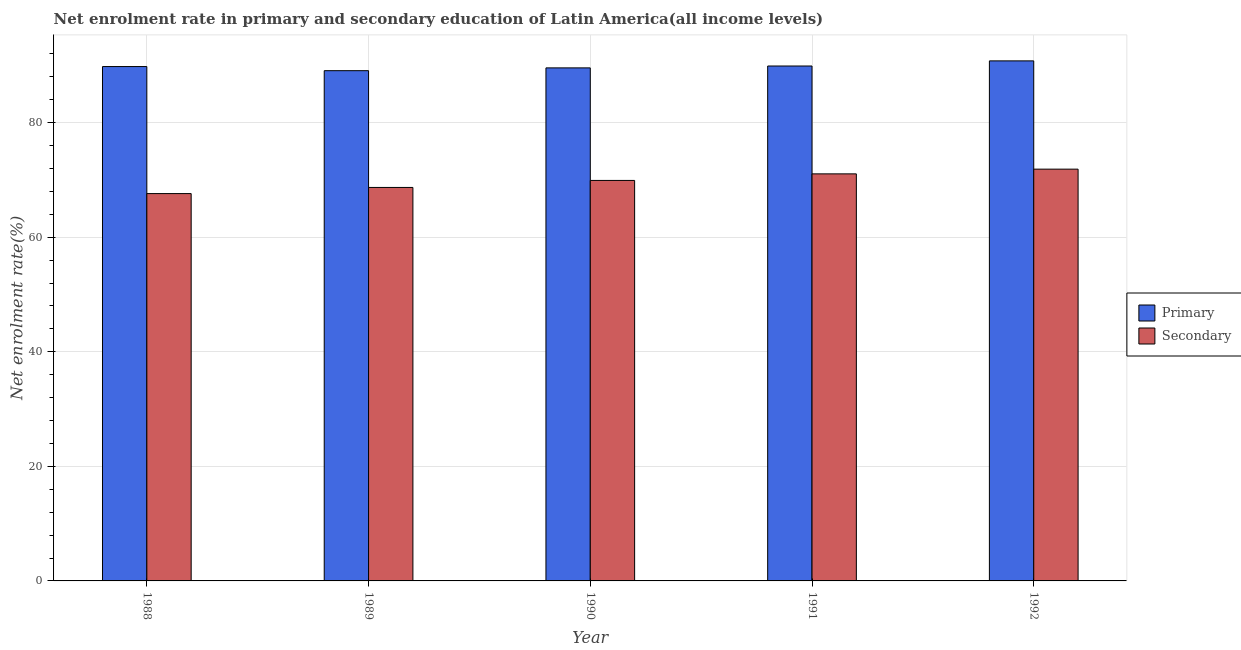How many different coloured bars are there?
Provide a short and direct response. 2. How many groups of bars are there?
Your answer should be compact. 5. What is the enrollment rate in primary education in 1988?
Provide a short and direct response. 89.8. Across all years, what is the maximum enrollment rate in primary education?
Keep it short and to the point. 90.79. Across all years, what is the minimum enrollment rate in primary education?
Keep it short and to the point. 89.08. What is the total enrollment rate in secondary education in the graph?
Keep it short and to the point. 349.18. What is the difference between the enrollment rate in secondary education in 1988 and that in 1990?
Keep it short and to the point. -2.3. What is the difference between the enrollment rate in secondary education in 1990 and the enrollment rate in primary education in 1989?
Your response must be concise. 1.22. What is the average enrollment rate in secondary education per year?
Ensure brevity in your answer.  69.84. What is the ratio of the enrollment rate in primary education in 1988 to that in 1990?
Your response must be concise. 1. Is the enrollment rate in primary education in 1988 less than that in 1991?
Offer a very short reply. Yes. Is the difference between the enrollment rate in secondary education in 1989 and 1992 greater than the difference between the enrollment rate in primary education in 1989 and 1992?
Offer a very short reply. No. What is the difference between the highest and the second highest enrollment rate in primary education?
Give a very brief answer. 0.9. What is the difference between the highest and the lowest enrollment rate in primary education?
Offer a very short reply. 1.71. Is the sum of the enrollment rate in secondary education in 1990 and 1992 greater than the maximum enrollment rate in primary education across all years?
Provide a succinct answer. Yes. What does the 2nd bar from the left in 1991 represents?
Keep it short and to the point. Secondary. What does the 2nd bar from the right in 1990 represents?
Offer a terse response. Primary. Are all the bars in the graph horizontal?
Your response must be concise. No. How many years are there in the graph?
Ensure brevity in your answer.  5. What is the difference between two consecutive major ticks on the Y-axis?
Provide a succinct answer. 20. Are the values on the major ticks of Y-axis written in scientific E-notation?
Provide a short and direct response. No. How many legend labels are there?
Provide a succinct answer. 2. What is the title of the graph?
Give a very brief answer. Net enrolment rate in primary and secondary education of Latin America(all income levels). What is the label or title of the X-axis?
Provide a succinct answer. Year. What is the label or title of the Y-axis?
Give a very brief answer. Net enrolment rate(%). What is the Net enrolment rate(%) in Primary in 1988?
Offer a very short reply. 89.8. What is the Net enrolment rate(%) of Secondary in 1988?
Make the answer very short. 67.62. What is the Net enrolment rate(%) of Primary in 1989?
Your answer should be compact. 89.08. What is the Net enrolment rate(%) of Secondary in 1989?
Your answer should be compact. 68.69. What is the Net enrolment rate(%) in Primary in 1990?
Ensure brevity in your answer.  89.57. What is the Net enrolment rate(%) in Secondary in 1990?
Your answer should be compact. 69.92. What is the Net enrolment rate(%) of Primary in 1991?
Your response must be concise. 89.89. What is the Net enrolment rate(%) of Secondary in 1991?
Ensure brevity in your answer.  71.06. What is the Net enrolment rate(%) in Primary in 1992?
Offer a very short reply. 90.79. What is the Net enrolment rate(%) in Secondary in 1992?
Provide a succinct answer. 71.89. Across all years, what is the maximum Net enrolment rate(%) in Primary?
Ensure brevity in your answer.  90.79. Across all years, what is the maximum Net enrolment rate(%) in Secondary?
Keep it short and to the point. 71.89. Across all years, what is the minimum Net enrolment rate(%) of Primary?
Offer a terse response. 89.08. Across all years, what is the minimum Net enrolment rate(%) of Secondary?
Ensure brevity in your answer.  67.62. What is the total Net enrolment rate(%) of Primary in the graph?
Keep it short and to the point. 449.13. What is the total Net enrolment rate(%) in Secondary in the graph?
Give a very brief answer. 349.18. What is the difference between the Net enrolment rate(%) of Primary in 1988 and that in 1989?
Keep it short and to the point. 0.72. What is the difference between the Net enrolment rate(%) of Secondary in 1988 and that in 1989?
Provide a short and direct response. -1.07. What is the difference between the Net enrolment rate(%) of Primary in 1988 and that in 1990?
Your response must be concise. 0.23. What is the difference between the Net enrolment rate(%) in Secondary in 1988 and that in 1990?
Offer a very short reply. -2.3. What is the difference between the Net enrolment rate(%) in Primary in 1988 and that in 1991?
Your answer should be very brief. -0.1. What is the difference between the Net enrolment rate(%) in Secondary in 1988 and that in 1991?
Your answer should be compact. -3.44. What is the difference between the Net enrolment rate(%) of Primary in 1988 and that in 1992?
Provide a short and direct response. -0.99. What is the difference between the Net enrolment rate(%) of Secondary in 1988 and that in 1992?
Keep it short and to the point. -4.27. What is the difference between the Net enrolment rate(%) of Primary in 1989 and that in 1990?
Keep it short and to the point. -0.49. What is the difference between the Net enrolment rate(%) of Secondary in 1989 and that in 1990?
Your answer should be very brief. -1.22. What is the difference between the Net enrolment rate(%) of Primary in 1989 and that in 1991?
Ensure brevity in your answer.  -0.81. What is the difference between the Net enrolment rate(%) in Secondary in 1989 and that in 1991?
Ensure brevity in your answer.  -2.37. What is the difference between the Net enrolment rate(%) in Primary in 1989 and that in 1992?
Provide a short and direct response. -1.71. What is the difference between the Net enrolment rate(%) in Secondary in 1989 and that in 1992?
Your response must be concise. -3.19. What is the difference between the Net enrolment rate(%) of Primary in 1990 and that in 1991?
Keep it short and to the point. -0.33. What is the difference between the Net enrolment rate(%) of Secondary in 1990 and that in 1991?
Make the answer very short. -1.15. What is the difference between the Net enrolment rate(%) of Primary in 1990 and that in 1992?
Ensure brevity in your answer.  -1.22. What is the difference between the Net enrolment rate(%) of Secondary in 1990 and that in 1992?
Your response must be concise. -1.97. What is the difference between the Net enrolment rate(%) of Primary in 1991 and that in 1992?
Your answer should be very brief. -0.9. What is the difference between the Net enrolment rate(%) of Secondary in 1991 and that in 1992?
Your response must be concise. -0.82. What is the difference between the Net enrolment rate(%) of Primary in 1988 and the Net enrolment rate(%) of Secondary in 1989?
Your answer should be very brief. 21.1. What is the difference between the Net enrolment rate(%) of Primary in 1988 and the Net enrolment rate(%) of Secondary in 1990?
Your answer should be compact. 19.88. What is the difference between the Net enrolment rate(%) in Primary in 1988 and the Net enrolment rate(%) in Secondary in 1991?
Provide a short and direct response. 18.73. What is the difference between the Net enrolment rate(%) of Primary in 1988 and the Net enrolment rate(%) of Secondary in 1992?
Provide a succinct answer. 17.91. What is the difference between the Net enrolment rate(%) in Primary in 1989 and the Net enrolment rate(%) in Secondary in 1990?
Offer a very short reply. 19.16. What is the difference between the Net enrolment rate(%) of Primary in 1989 and the Net enrolment rate(%) of Secondary in 1991?
Your answer should be compact. 18.02. What is the difference between the Net enrolment rate(%) of Primary in 1989 and the Net enrolment rate(%) of Secondary in 1992?
Your response must be concise. 17.19. What is the difference between the Net enrolment rate(%) of Primary in 1990 and the Net enrolment rate(%) of Secondary in 1991?
Make the answer very short. 18.5. What is the difference between the Net enrolment rate(%) in Primary in 1990 and the Net enrolment rate(%) in Secondary in 1992?
Keep it short and to the point. 17.68. What is the difference between the Net enrolment rate(%) of Primary in 1991 and the Net enrolment rate(%) of Secondary in 1992?
Provide a succinct answer. 18.01. What is the average Net enrolment rate(%) in Primary per year?
Provide a short and direct response. 89.83. What is the average Net enrolment rate(%) in Secondary per year?
Provide a succinct answer. 69.84. In the year 1988, what is the difference between the Net enrolment rate(%) in Primary and Net enrolment rate(%) in Secondary?
Your answer should be very brief. 22.18. In the year 1989, what is the difference between the Net enrolment rate(%) of Primary and Net enrolment rate(%) of Secondary?
Your answer should be compact. 20.39. In the year 1990, what is the difference between the Net enrolment rate(%) of Primary and Net enrolment rate(%) of Secondary?
Provide a short and direct response. 19.65. In the year 1991, what is the difference between the Net enrolment rate(%) in Primary and Net enrolment rate(%) in Secondary?
Your answer should be very brief. 18.83. In the year 1992, what is the difference between the Net enrolment rate(%) in Primary and Net enrolment rate(%) in Secondary?
Provide a succinct answer. 18.9. What is the ratio of the Net enrolment rate(%) of Primary in 1988 to that in 1989?
Offer a terse response. 1.01. What is the ratio of the Net enrolment rate(%) of Secondary in 1988 to that in 1989?
Give a very brief answer. 0.98. What is the ratio of the Net enrolment rate(%) of Secondary in 1988 to that in 1990?
Give a very brief answer. 0.97. What is the ratio of the Net enrolment rate(%) of Secondary in 1988 to that in 1991?
Provide a succinct answer. 0.95. What is the ratio of the Net enrolment rate(%) of Secondary in 1988 to that in 1992?
Make the answer very short. 0.94. What is the ratio of the Net enrolment rate(%) of Secondary in 1989 to that in 1990?
Your answer should be very brief. 0.98. What is the ratio of the Net enrolment rate(%) of Primary in 1989 to that in 1991?
Make the answer very short. 0.99. What is the ratio of the Net enrolment rate(%) of Secondary in 1989 to that in 1991?
Provide a short and direct response. 0.97. What is the ratio of the Net enrolment rate(%) in Primary in 1989 to that in 1992?
Ensure brevity in your answer.  0.98. What is the ratio of the Net enrolment rate(%) in Secondary in 1989 to that in 1992?
Give a very brief answer. 0.96. What is the ratio of the Net enrolment rate(%) of Primary in 1990 to that in 1991?
Ensure brevity in your answer.  1. What is the ratio of the Net enrolment rate(%) in Secondary in 1990 to that in 1991?
Ensure brevity in your answer.  0.98. What is the ratio of the Net enrolment rate(%) in Primary in 1990 to that in 1992?
Ensure brevity in your answer.  0.99. What is the ratio of the Net enrolment rate(%) of Secondary in 1990 to that in 1992?
Provide a succinct answer. 0.97. What is the ratio of the Net enrolment rate(%) of Secondary in 1991 to that in 1992?
Ensure brevity in your answer.  0.99. What is the difference between the highest and the second highest Net enrolment rate(%) in Primary?
Your answer should be compact. 0.9. What is the difference between the highest and the second highest Net enrolment rate(%) of Secondary?
Offer a very short reply. 0.82. What is the difference between the highest and the lowest Net enrolment rate(%) in Primary?
Make the answer very short. 1.71. What is the difference between the highest and the lowest Net enrolment rate(%) in Secondary?
Offer a terse response. 4.27. 